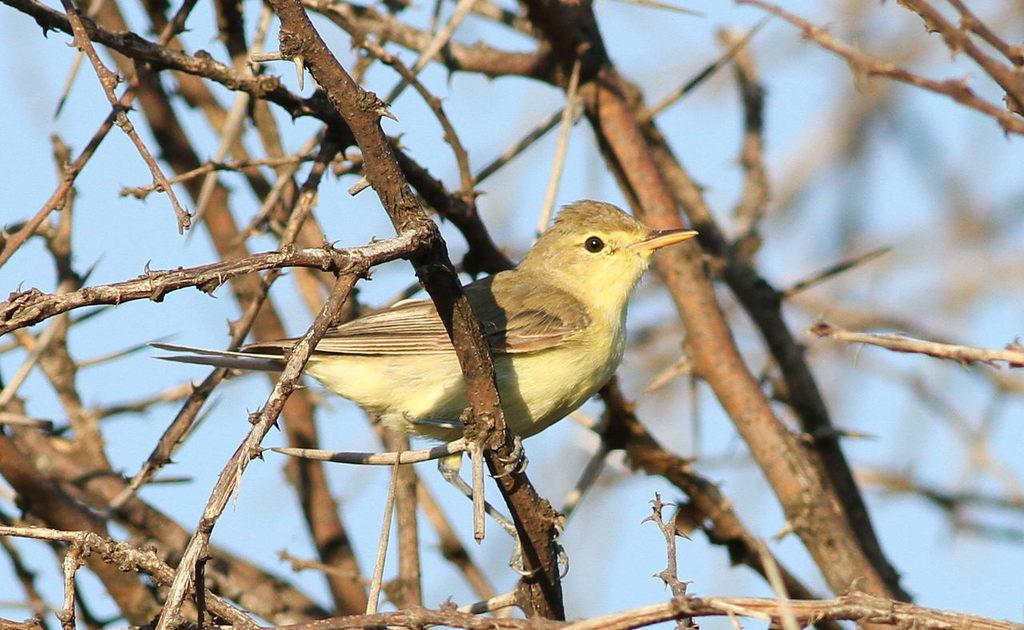What can be seen growing in the image? There are stems in the image. Is there any wildlife present on the stems? Yes, there is a bird on a stem in the image. In which direction is the bird facing? The bird is facing towards the right side. What can be seen in the background of the image? There is sky visible in the background of the image. What type of patch is the bird trying to jump over in the image? There is no patch or jumping activity present in the image; it features a bird on a stem facing towards the right side. 